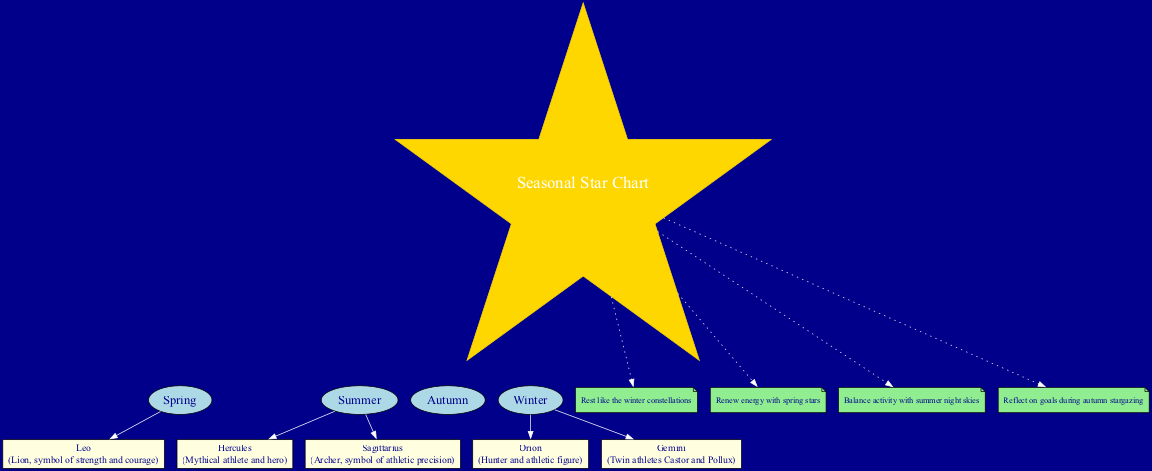What season is Hercules visible? Hercules is listed under the summer constellations in the diagram. Thus, when asked about the season where Hercules is visible, we refer to its associated season.
Answer: Summer Which constellation is associated with the symbol of athletic precision? Sagittarius is the constellation that is described as the archer, which symbolizes athletic precision. It is connected to the summer season, making it relevant during that time.
Answer: Sagittarius How many constellations are mentioned in the diagram? Counting the constellations listed, we find five: Hercules, Orion, Gemini, Sagittarius, and Leo. Thus, the question about their total leads us to sum them.
Answer: 5 What is the self-care reminder associated with winter? In the diagram, the self-care reminder specifically linked to winter is "Rest like the winter constellations." By locating the winter section, we can quickly identify this reminder.
Answer: Rest like the winter constellations Which two constellations are linked to winter? The winter constellations identified in the diagram are Orion and Gemini. To answer this question, we refer back to the constellations listed under the winter section.
Answer: Orion and Gemini What do the spring stars help to do? According to the diagram, the self-care reminder for spring is "Renew energy with spring stars." This statement clearly outlines the role of the spring stars.
Answer: Renew energy What is the relationship between Leo and strength? Leo is described as the lion, which represents strength and courage. Therefore, the relationship between Leo and strength is a symbolic one as outlined in the diagram's description.
Answer: Strength Which constellation is represented by twin athletes? Gemini represents the twin athletes in the diagram. This description directly links Gemini to the idea of being associated with twin athletes Castor and Pollux.
Answer: Gemini How does the diagram suggest balancing activity? The diagram advises to "Balance activity with summer night skies." This specific self-care reminder highlights the importance of finding balance during the summer season.
Answer: Balance activity with summer night skies 